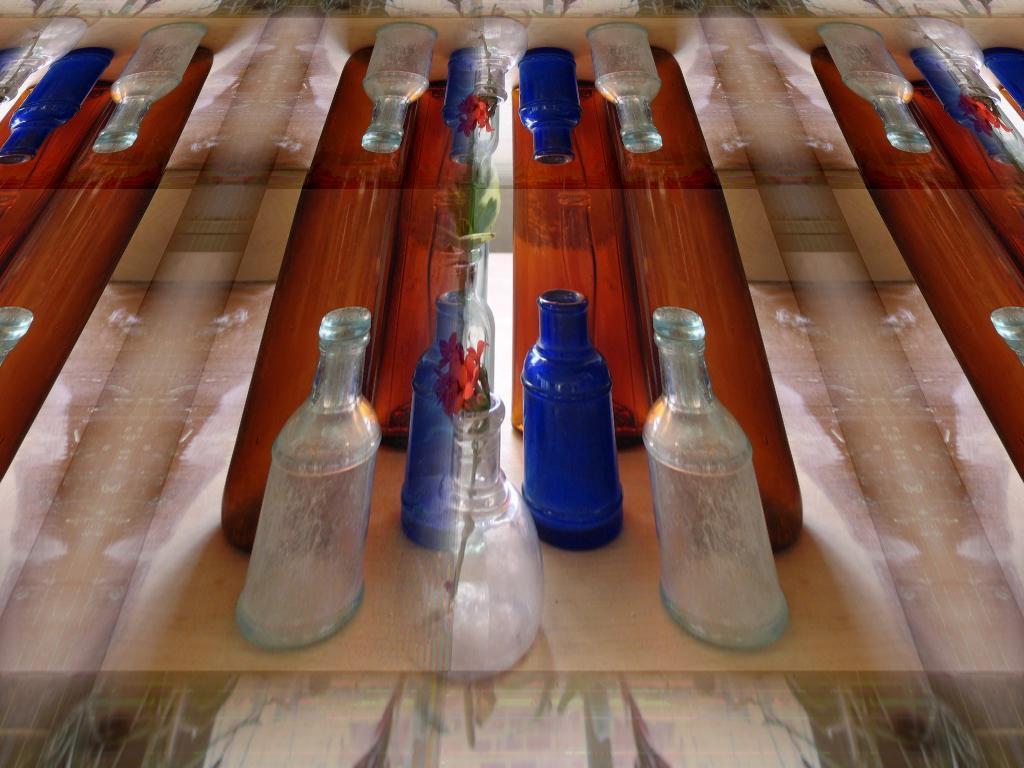Please provide a concise description of this image. In this image i can see few bottles and a flower pot on a table. 